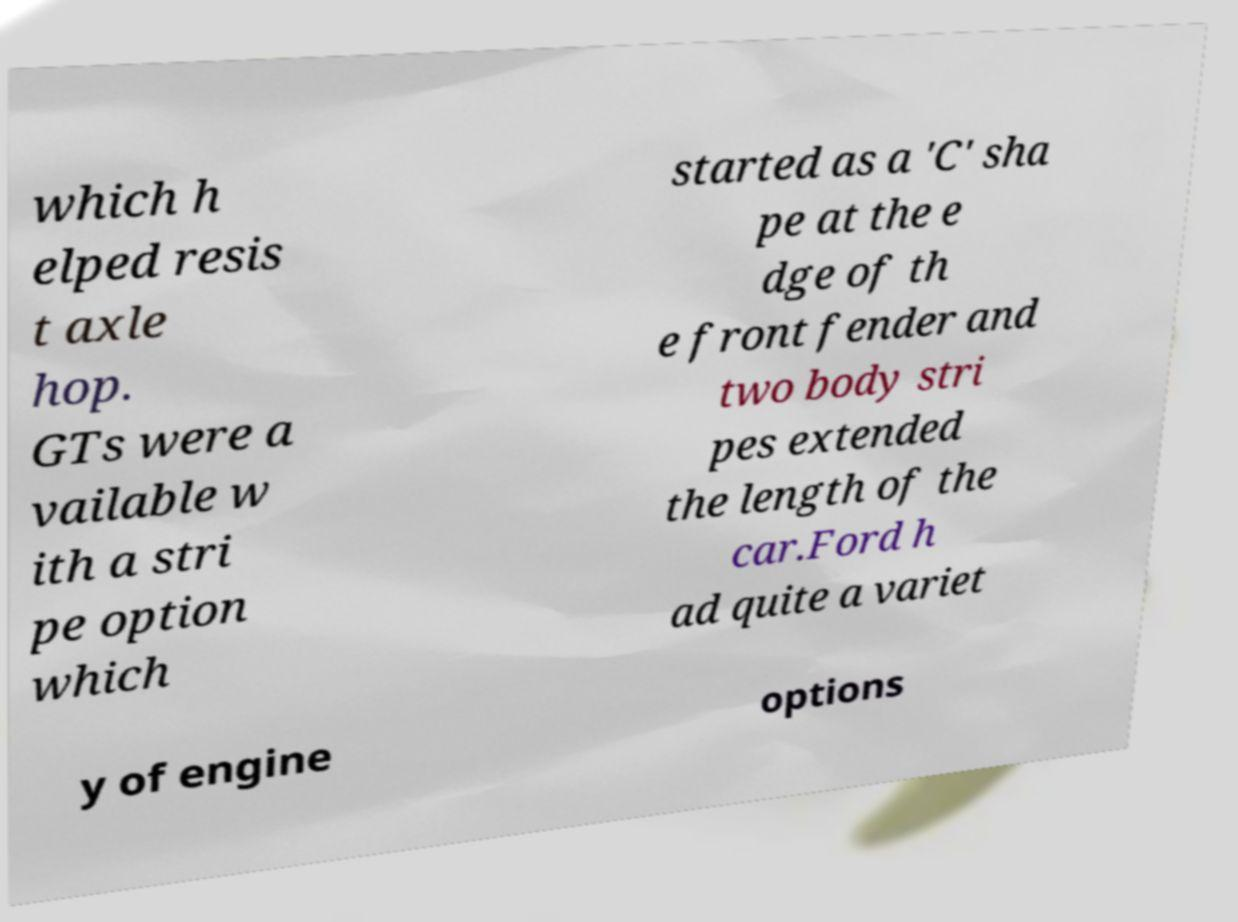Can you accurately transcribe the text from the provided image for me? which h elped resis t axle hop. GTs were a vailable w ith a stri pe option which started as a 'C' sha pe at the e dge of th e front fender and two body stri pes extended the length of the car.Ford h ad quite a variet y of engine options 